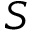Convert formula to latex. <formula><loc_0><loc_0><loc_500><loc_500>S</formula> 